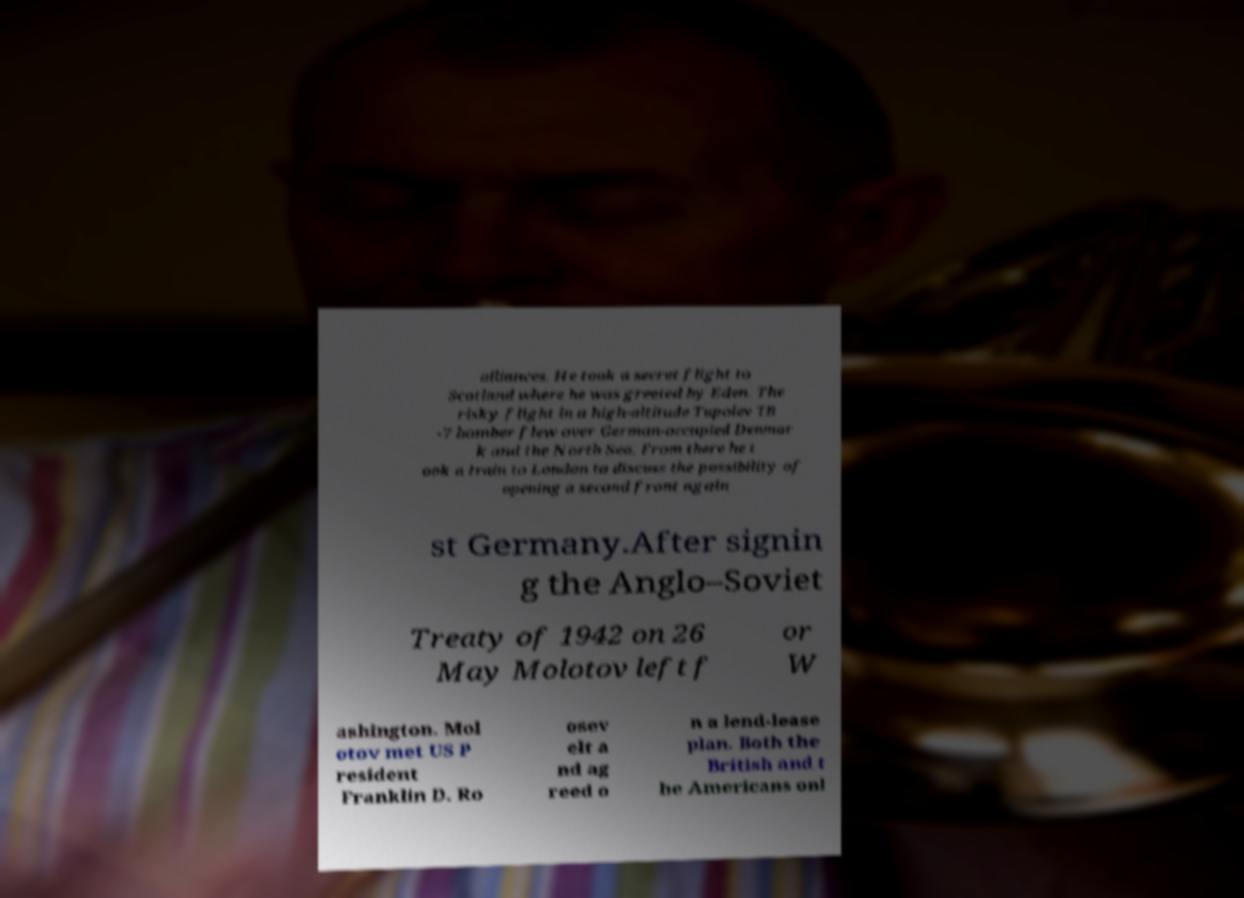There's text embedded in this image that I need extracted. Can you transcribe it verbatim? alliances. He took a secret flight to Scotland where he was greeted by Eden. The risky flight in a high-altitude Tupolev TB -7 bomber flew over German-occupied Denmar k and the North Sea. From there he t ook a train to London to discuss the possibility of opening a second front again st Germany.After signin g the Anglo–Soviet Treaty of 1942 on 26 May Molotov left f or W ashington. Mol otov met US P resident Franklin D. Ro osev elt a nd ag reed o n a lend-lease plan. Both the British and t he Americans onl 